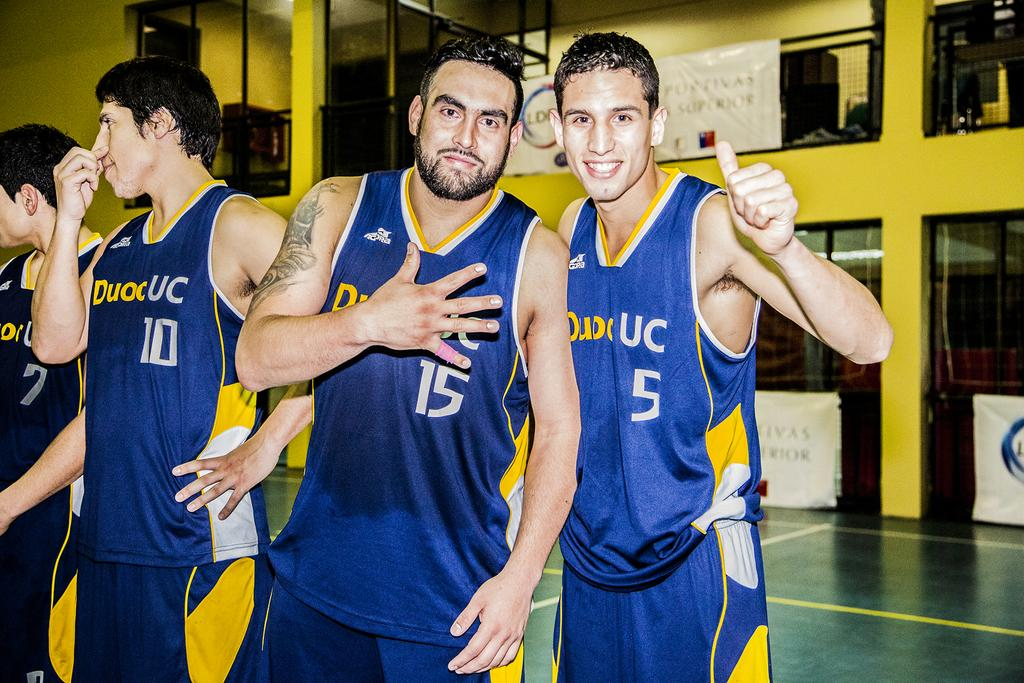<image>
Write a terse but informative summary of the picture. Two Duoc UC basketball players pose for a picture next to teammate number 10. 